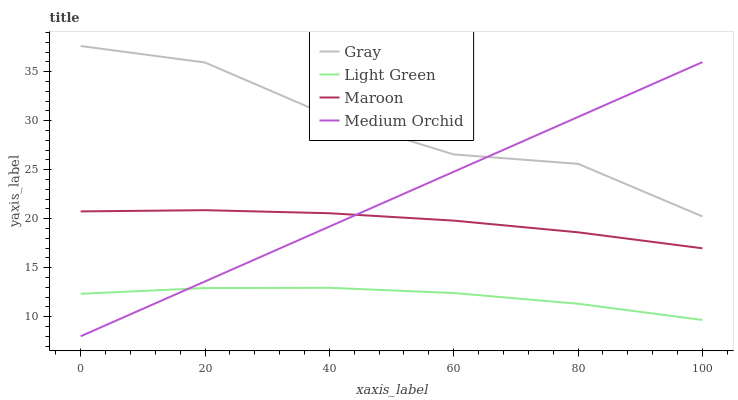Does Medium Orchid have the minimum area under the curve?
Answer yes or no. No. Does Medium Orchid have the maximum area under the curve?
Answer yes or no. No. Is Maroon the smoothest?
Answer yes or no. No. Is Maroon the roughest?
Answer yes or no. No. Does Maroon have the lowest value?
Answer yes or no. No. Does Medium Orchid have the highest value?
Answer yes or no. No. Is Light Green less than Gray?
Answer yes or no. Yes. Is Gray greater than Light Green?
Answer yes or no. Yes. Does Light Green intersect Gray?
Answer yes or no. No. 